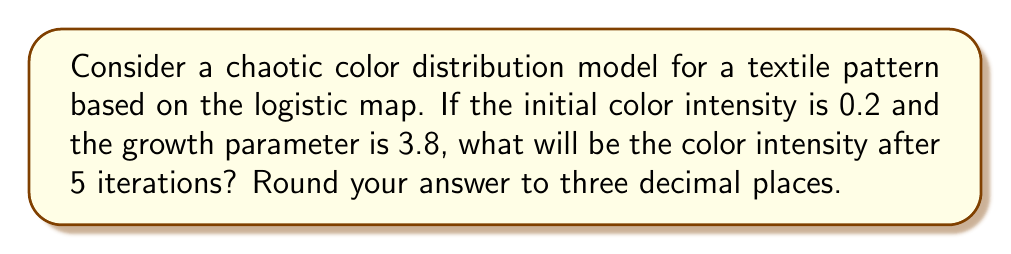Could you help me with this problem? To solve this problem, we'll use the logistic map equation:

$$x_{n+1} = r x_n (1 - x_n)$$

Where:
$x_n$ is the color intensity at iteration n
$r$ is the growth parameter
$x_0$ is the initial color intensity

Given:
$x_0 = 0.2$
$r = 3.8$

Let's calculate the color intensity for each iteration:

1. First iteration:
   $$x_1 = 3.8 \cdot 0.2 \cdot (1 - 0.2) = 0.608$$

2. Second iteration:
   $$x_2 = 3.8 \cdot 0.608 \cdot (1 - 0.608) = 0.90989056$$

3. Third iteration:
   $$x_3 = 3.8 \cdot 0.90989056 \cdot (1 - 0.90989056) = 0.31385281$$

4. Fourth iteration:
   $$x_4 = 3.8 \cdot 0.31385281 \cdot (1 - 0.31385281) = 0.81872408$$

5. Fifth iteration:
   $$x_5 = 3.8 \cdot 0.81872408 \cdot (1 - 0.81872408) = 0.56615927$$

Rounding to three decimal places, we get 0.566.
Answer: 0.566 